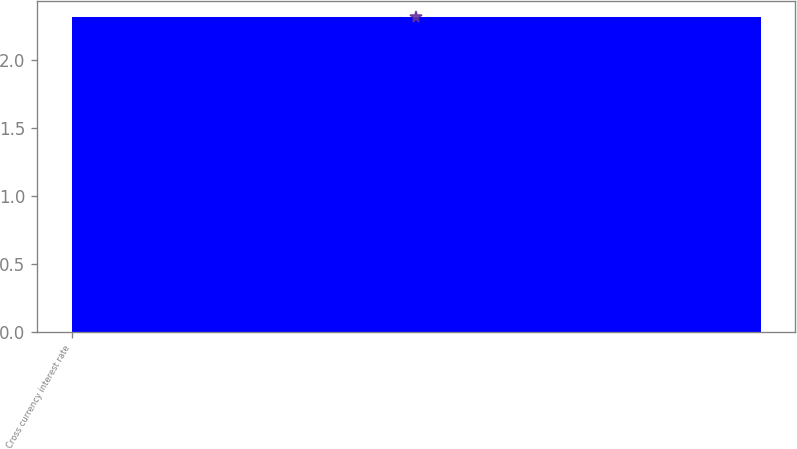<chart> <loc_0><loc_0><loc_500><loc_500><bar_chart><fcel>Cross currency interest rate<nl><fcel>2.32<nl></chart> 